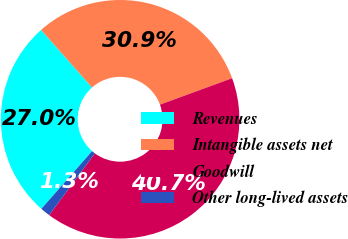Convert chart. <chart><loc_0><loc_0><loc_500><loc_500><pie_chart><fcel>Revenues<fcel>Intangible assets net<fcel>Goodwill<fcel>Other long-lived assets<nl><fcel>27.0%<fcel>30.94%<fcel>40.74%<fcel>1.33%<nl></chart> 